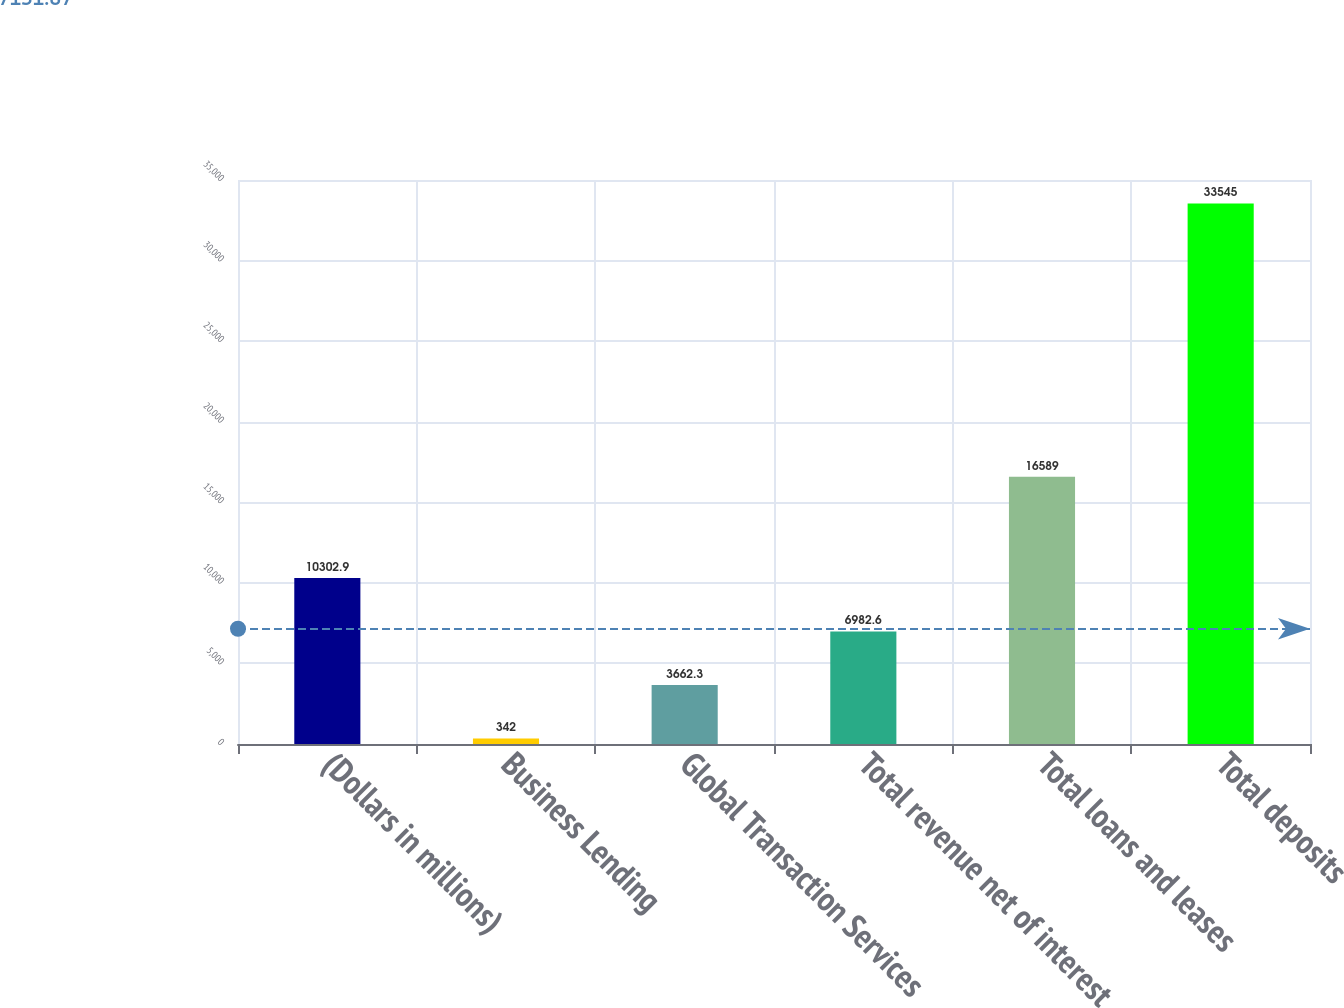Convert chart. <chart><loc_0><loc_0><loc_500><loc_500><bar_chart><fcel>(Dollars in millions)<fcel>Business Lending<fcel>Global Transaction Services<fcel>Total revenue net of interest<fcel>Total loans and leases<fcel>Total deposits<nl><fcel>10302.9<fcel>342<fcel>3662.3<fcel>6982.6<fcel>16589<fcel>33545<nl></chart> 